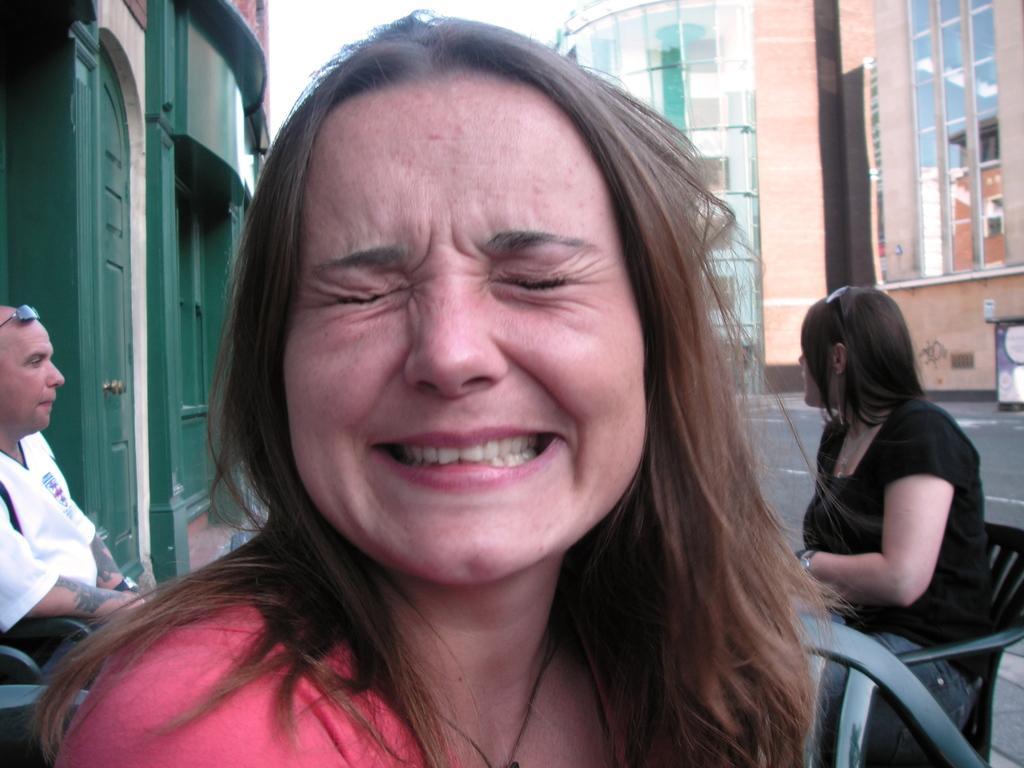Please provide a concise description of this image. In this picture there is a woman sitting on the chair. At the back there are two persons sitting on the chair and there are buildings. At the top there is sky. At the bottom there is a road. On the left side of the image there is a door. 